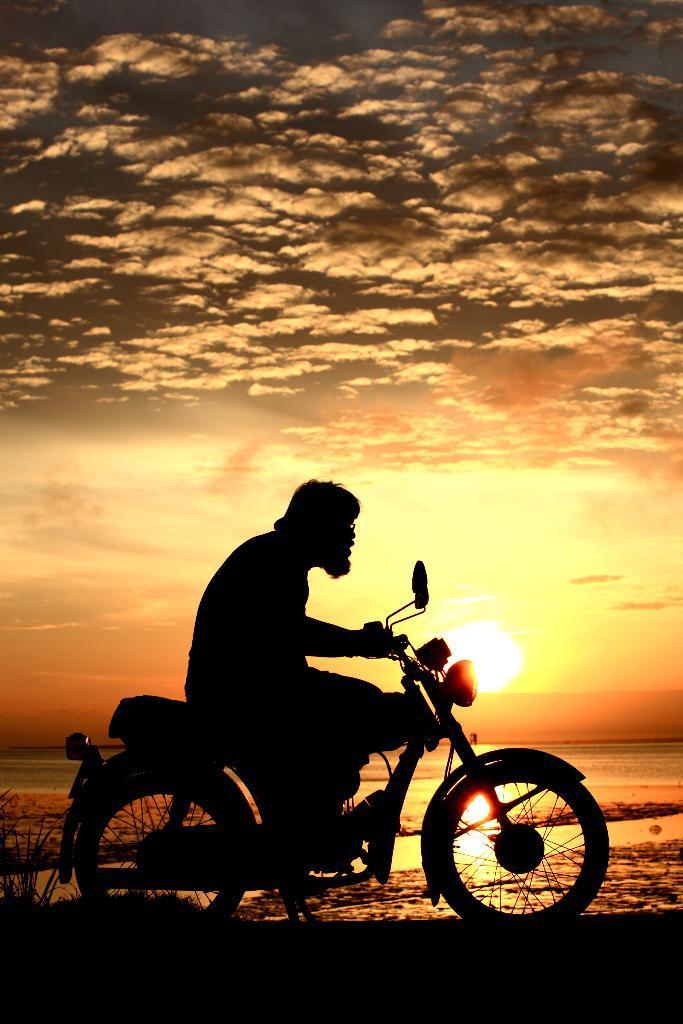Can you describe this image briefly? In the image there is a guy on a bike, above its sky with clouds and at background there is sea and the sun is setting off. 